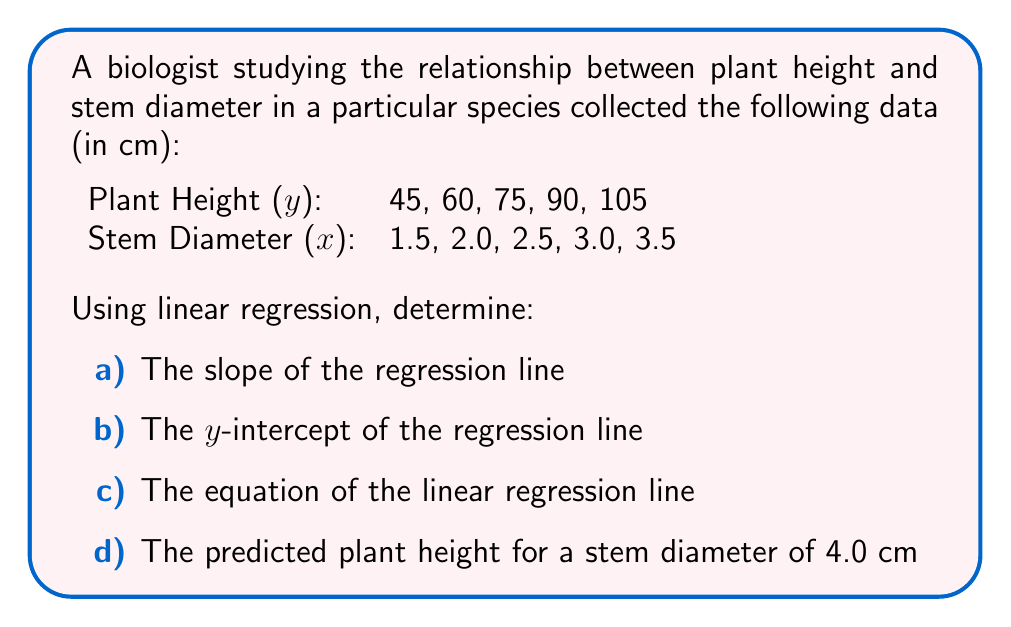Could you help me with this problem? Let's approach this step-by-step using linear regression formulas:

1) First, we need to calculate some preliminary values:
   $n = 5$ (number of data points)
   $\sum x = 12.5$
   $\sum y = 375$
   $\sum xy = 1012.5$
   $\sum x^2 = 33.25$
   $(\sum x)^2 = 156.25$

2) Calculate the slope (m):
   $$m = \frac{n\sum xy - \sum x \sum y}{n\sum x^2 - (\sum x)^2}$$
   $$m = \frac{5(1012.5) - 12.5(375)}{5(33.25) - 156.25} = \frac{5062.5 - 4687.5}{166.25 - 156.25} = \frac{375}{10} = 37.5$$

3) Calculate the y-intercept (b):
   $$b = \frac{\sum y - m\sum x}{n}$$
   $$b = \frac{375 - 37.5(12.5)}{5} = \frac{375 - 468.75}{5} = -18.75$$

4) The equation of the linear regression line is:
   $$y = mx + b$$
   $$y = 37.5x - 18.75$$

5) To predict the plant height for a stem diameter of 4.0 cm, we substitute x = 4.0 into our equation:
   $$y = 37.5(4.0) - 18.75 = 150 - 18.75 = 131.25$$

Therefore:
a) The slope is 37.5 cm/cm
b) The y-intercept is -18.75 cm
c) The equation is y = 37.5x - 18.75
d) The predicted plant height for a stem diameter of 4.0 cm is 131.25 cm
Answer: a) 37.5 cm/cm
b) -18.75 cm
c) y = 37.5x - 18.75
d) 131.25 cm 